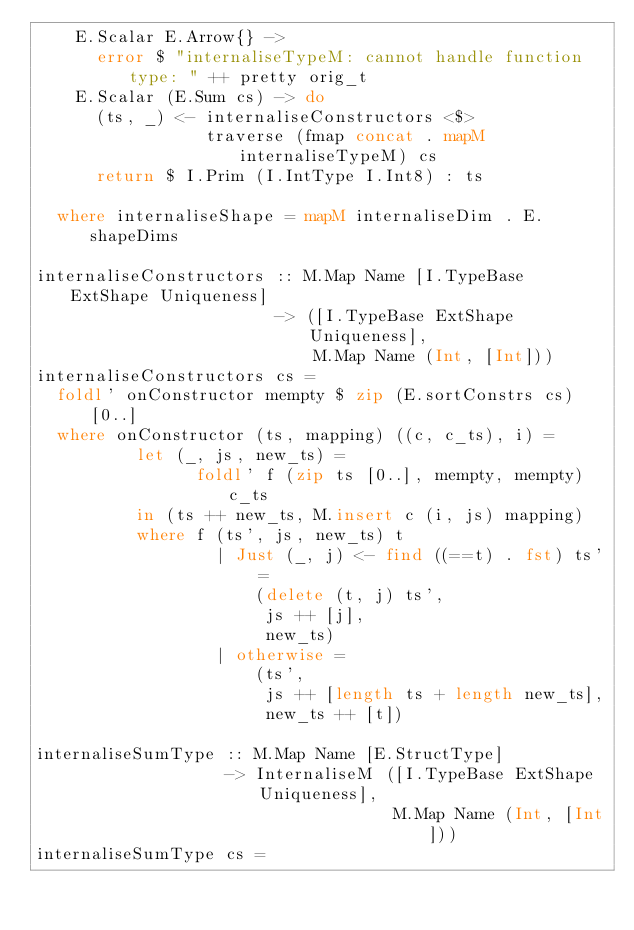<code> <loc_0><loc_0><loc_500><loc_500><_Haskell_>    E.Scalar E.Arrow{} ->
      error $ "internaliseTypeM: cannot handle function type: " ++ pretty orig_t
    E.Scalar (E.Sum cs) -> do
      (ts, _) <- internaliseConstructors <$>
                 traverse (fmap concat . mapM internaliseTypeM) cs
      return $ I.Prim (I.IntType I.Int8) : ts

  where internaliseShape = mapM internaliseDim . E.shapeDims

internaliseConstructors :: M.Map Name [I.TypeBase ExtShape Uniqueness]
                        -> ([I.TypeBase ExtShape Uniqueness],
                            M.Map Name (Int, [Int]))
internaliseConstructors cs =
  foldl' onConstructor mempty $ zip (E.sortConstrs cs) [0..]
  where onConstructor (ts, mapping) ((c, c_ts), i) =
          let (_, js, new_ts) =
                foldl' f (zip ts [0..], mempty, mempty) c_ts
          in (ts ++ new_ts, M.insert c (i, js) mapping)
          where f (ts', js, new_ts) t
                  | Just (_, j) <- find ((==t) . fst) ts' =
                      (delete (t, j) ts',
                       js ++ [j],
                       new_ts)
                  | otherwise =
                      (ts',
                       js ++ [length ts + length new_ts],
                       new_ts ++ [t])

internaliseSumType :: M.Map Name [E.StructType]
                   -> InternaliseM ([I.TypeBase ExtShape Uniqueness],
                                    M.Map Name (Int, [Int]))
internaliseSumType cs =</code> 